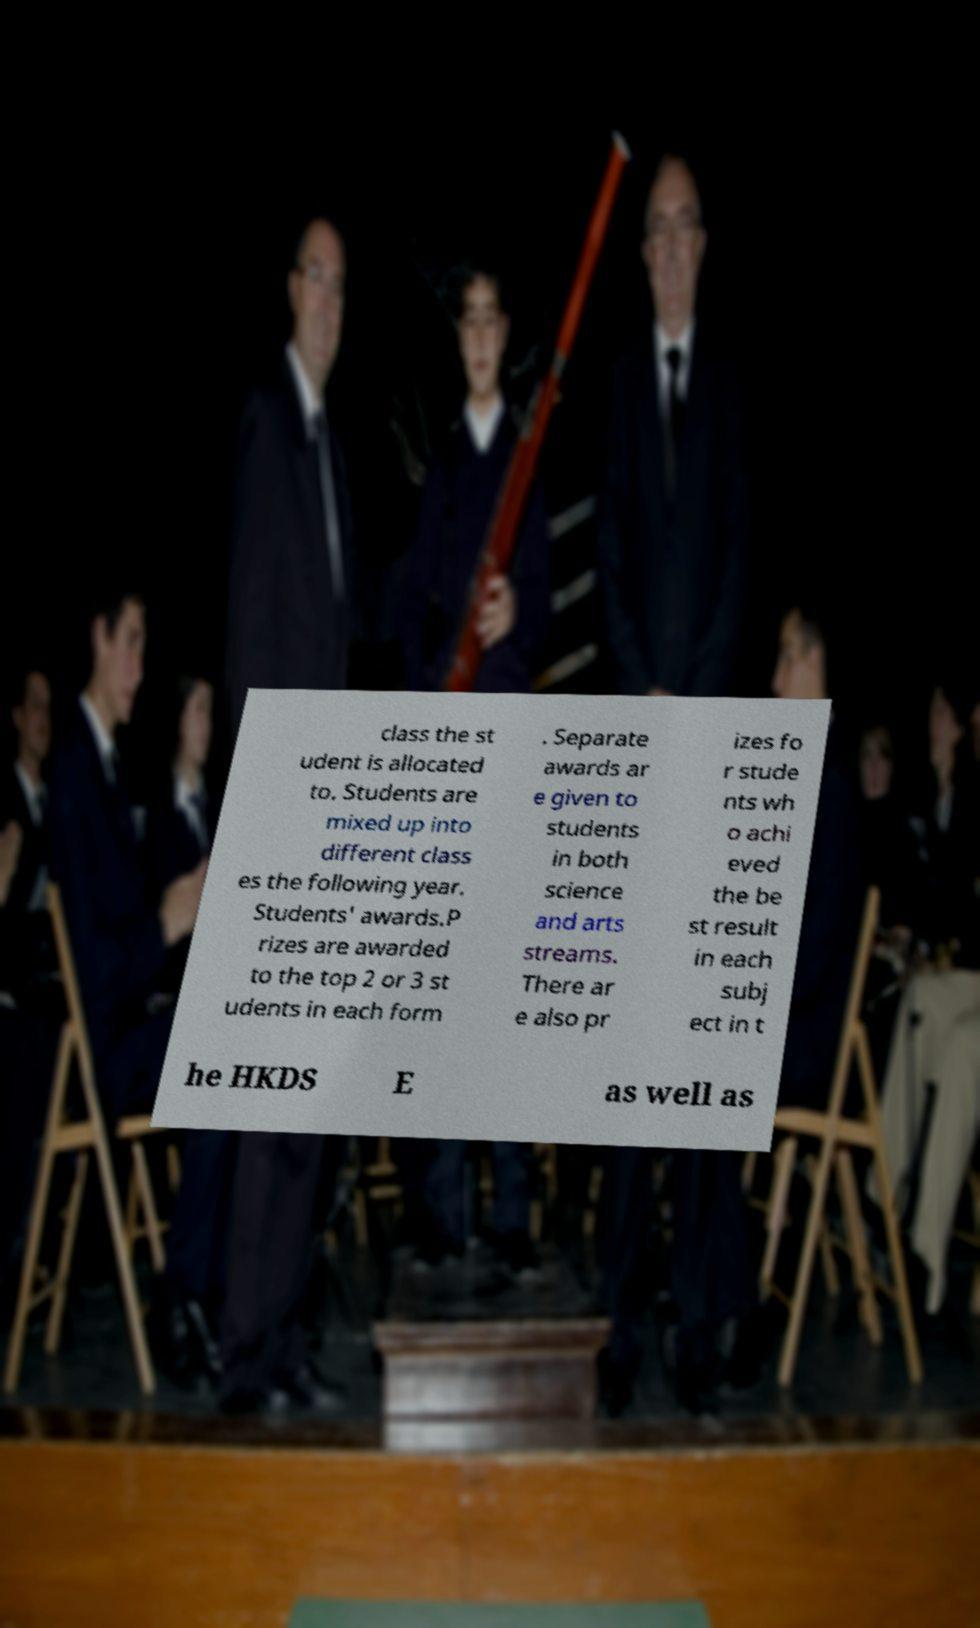There's text embedded in this image that I need extracted. Can you transcribe it verbatim? class the st udent is allocated to. Students are mixed up into different class es the following year. Students' awards.P rizes are awarded to the top 2 or 3 st udents in each form . Separate awards ar e given to students in both science and arts streams. There ar e also pr izes fo r stude nts wh o achi eved the be st result in each subj ect in t he HKDS E as well as 